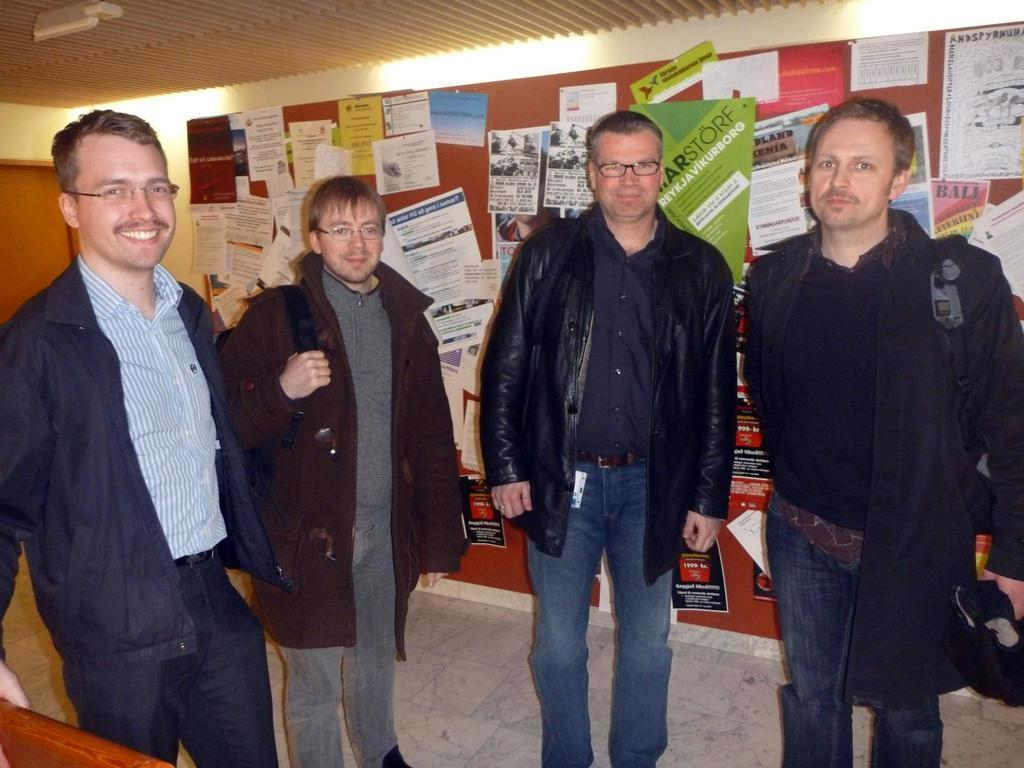How many people are in the group shown in the image? There is a group of people in the image, but the exact number is not specified. What can be observed about some of the people in the group? Some people in the group are wearing spectacles. What can be seen illuminating the scene in the image? There are lights visible in the image. What type of decorations are present on the wall in the image? There are posters on the wall in the image. What caption is written on the poster in the image? There is no caption visible on the posters in the image; only the images on the posters can be seen. Can you tell me how many people are kicking a ball in the image? There is no ball or kicking activity present in the image. 